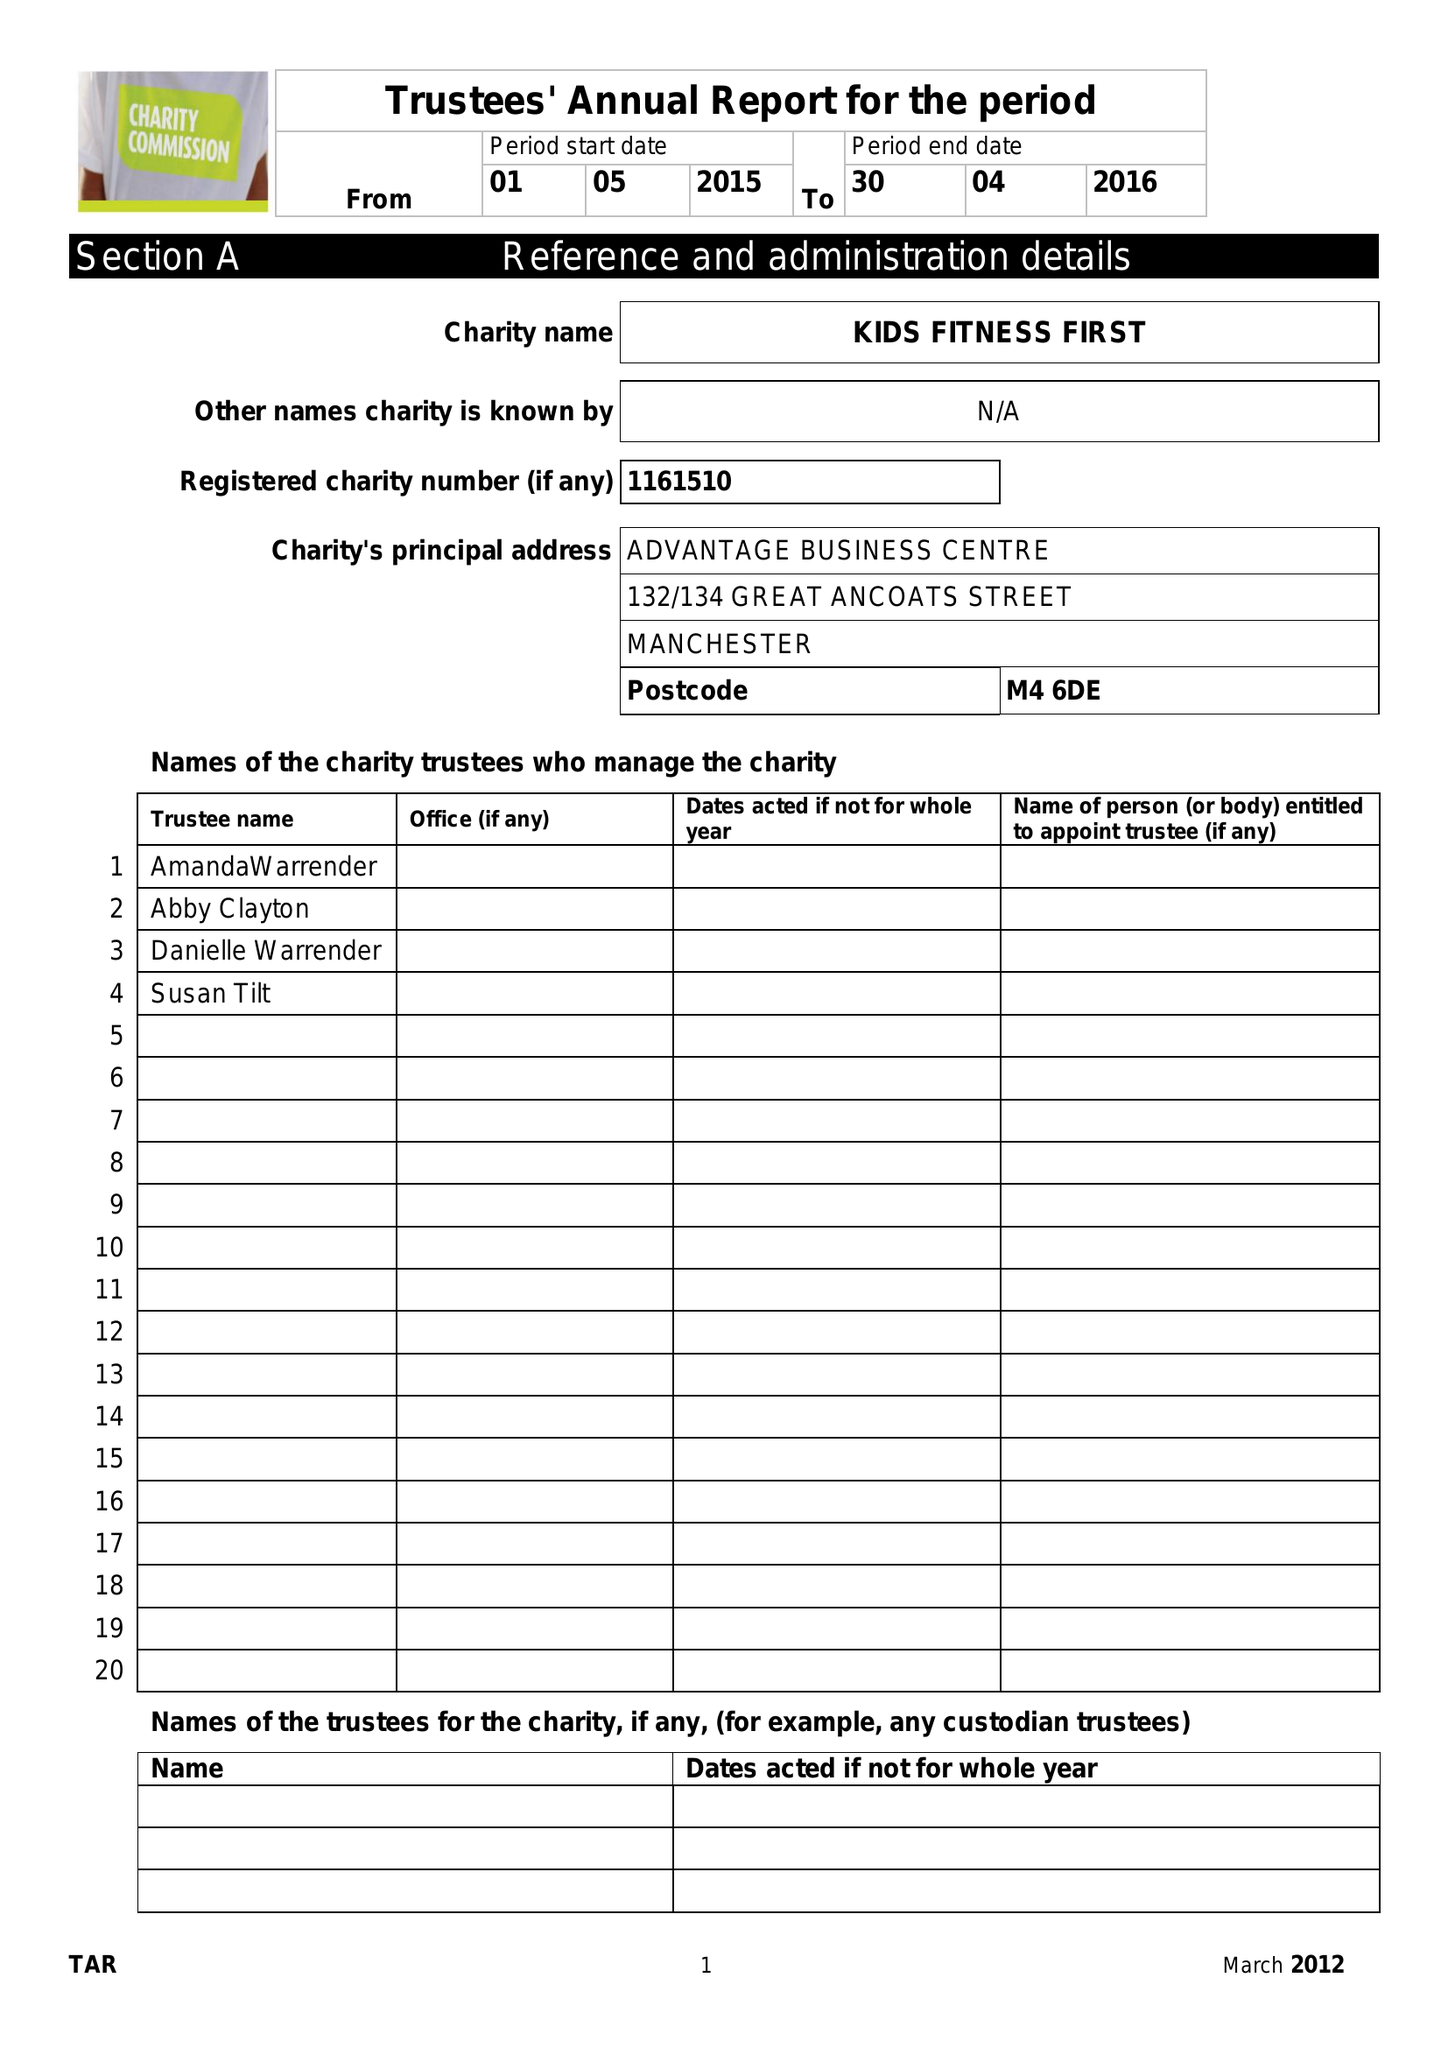What is the value for the address__post_town?
Answer the question using a single word or phrase. MANCHESTER 